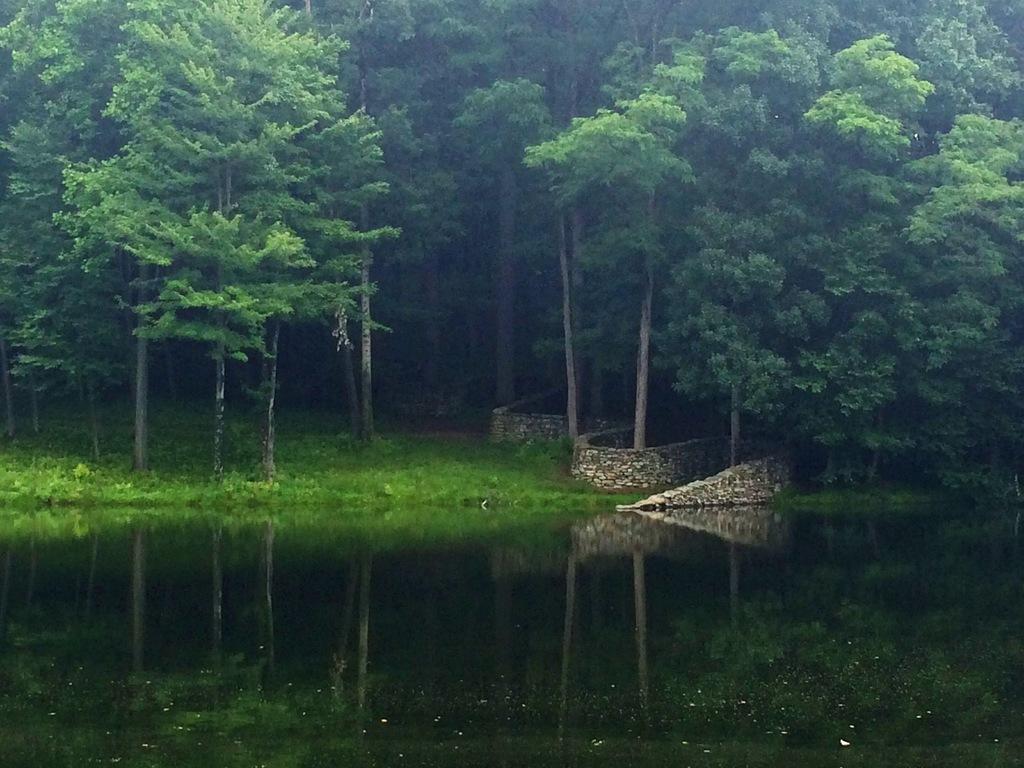Please provide a concise description of this image. At the bottom of the image there is water. Behind the water on the ground there is grass and also there is a stone wall. In the background there are many trees. 